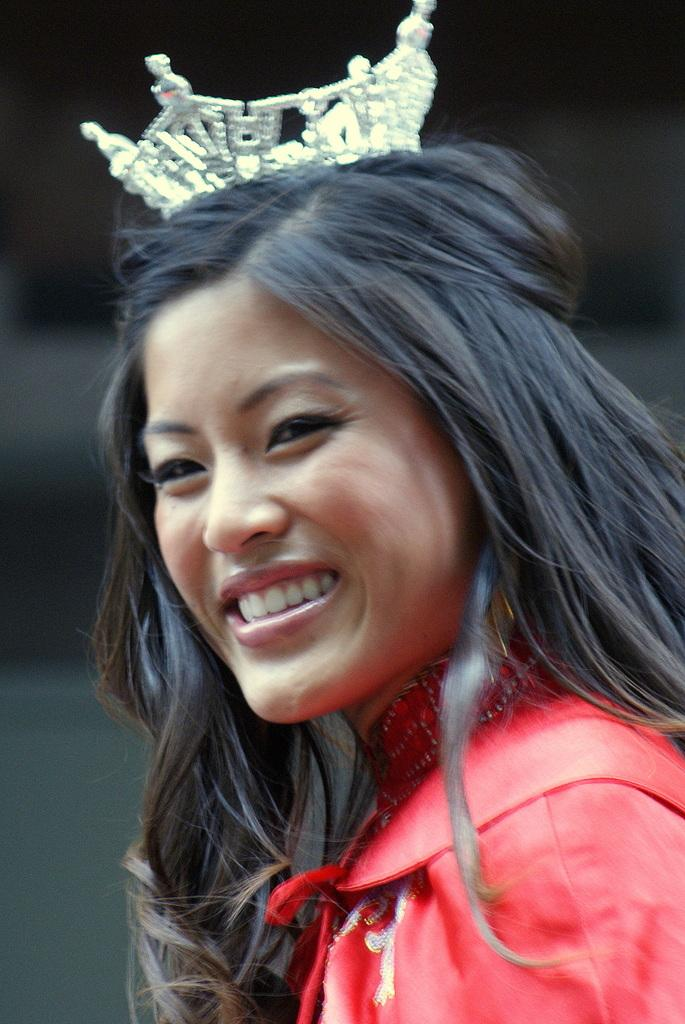Who is present in the image? There is a woman in the image. What is the woman wearing on her head? The woman is wearing a crown on her head. What type of wool is the woman using to communicate in the image? There is no wool or language mentioned in the image, and the woman is not using any wool to communicate. 